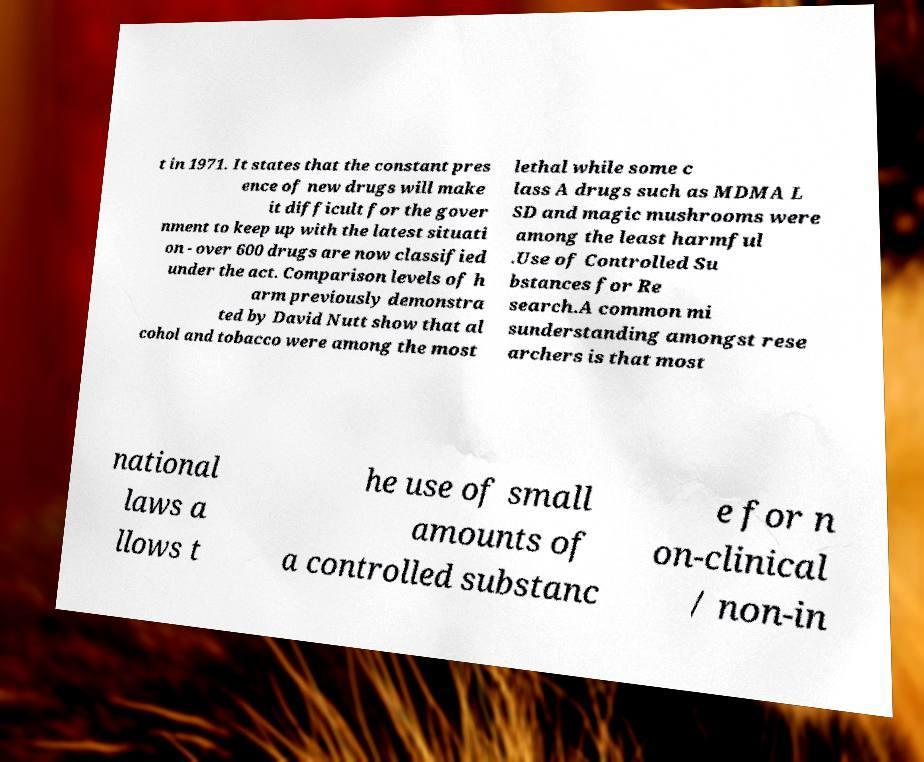I need the written content from this picture converted into text. Can you do that? t in 1971. It states that the constant pres ence of new drugs will make it difficult for the gover nment to keep up with the latest situati on - over 600 drugs are now classified under the act. Comparison levels of h arm previously demonstra ted by David Nutt show that al cohol and tobacco were among the most lethal while some c lass A drugs such as MDMA L SD and magic mushrooms were among the least harmful .Use of Controlled Su bstances for Re search.A common mi sunderstanding amongst rese archers is that most national laws a llows t he use of small amounts of a controlled substanc e for n on-clinical / non-in 